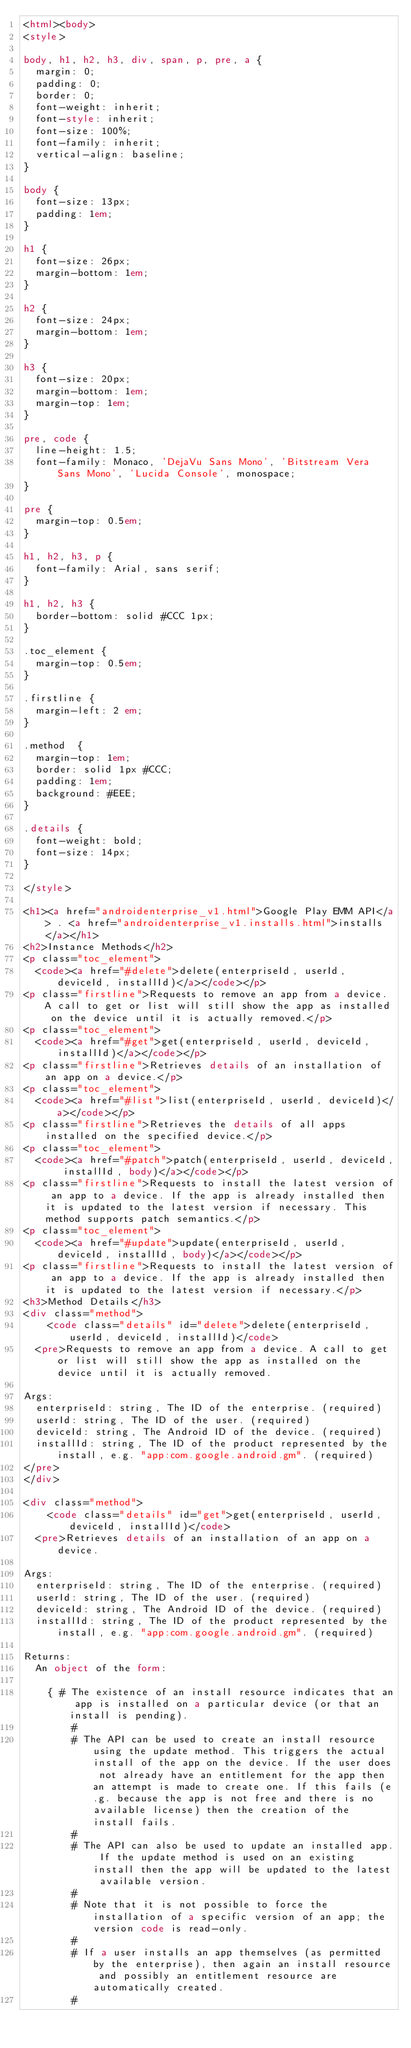Convert code to text. <code><loc_0><loc_0><loc_500><loc_500><_HTML_><html><body>
<style>

body, h1, h2, h3, div, span, p, pre, a {
  margin: 0;
  padding: 0;
  border: 0;
  font-weight: inherit;
  font-style: inherit;
  font-size: 100%;
  font-family: inherit;
  vertical-align: baseline;
}

body {
  font-size: 13px;
  padding: 1em;
}

h1 {
  font-size: 26px;
  margin-bottom: 1em;
}

h2 {
  font-size: 24px;
  margin-bottom: 1em;
}

h3 {
  font-size: 20px;
  margin-bottom: 1em;
  margin-top: 1em;
}

pre, code {
  line-height: 1.5;
  font-family: Monaco, 'DejaVu Sans Mono', 'Bitstream Vera Sans Mono', 'Lucida Console', monospace;
}

pre {
  margin-top: 0.5em;
}

h1, h2, h3, p {
  font-family: Arial, sans serif;
}

h1, h2, h3 {
  border-bottom: solid #CCC 1px;
}

.toc_element {
  margin-top: 0.5em;
}

.firstline {
  margin-left: 2 em;
}

.method  {
  margin-top: 1em;
  border: solid 1px #CCC;
  padding: 1em;
  background: #EEE;
}

.details {
  font-weight: bold;
  font-size: 14px;
}

</style>

<h1><a href="androidenterprise_v1.html">Google Play EMM API</a> . <a href="androidenterprise_v1.installs.html">installs</a></h1>
<h2>Instance Methods</h2>
<p class="toc_element">
  <code><a href="#delete">delete(enterpriseId, userId, deviceId, installId)</a></code></p>
<p class="firstline">Requests to remove an app from a device. A call to get or list will still show the app as installed on the device until it is actually removed.</p>
<p class="toc_element">
  <code><a href="#get">get(enterpriseId, userId, deviceId, installId)</a></code></p>
<p class="firstline">Retrieves details of an installation of an app on a device.</p>
<p class="toc_element">
  <code><a href="#list">list(enterpriseId, userId, deviceId)</a></code></p>
<p class="firstline">Retrieves the details of all apps installed on the specified device.</p>
<p class="toc_element">
  <code><a href="#patch">patch(enterpriseId, userId, deviceId, installId, body)</a></code></p>
<p class="firstline">Requests to install the latest version of an app to a device. If the app is already installed then it is updated to the latest version if necessary. This method supports patch semantics.</p>
<p class="toc_element">
  <code><a href="#update">update(enterpriseId, userId, deviceId, installId, body)</a></code></p>
<p class="firstline">Requests to install the latest version of an app to a device. If the app is already installed then it is updated to the latest version if necessary.</p>
<h3>Method Details</h3>
<div class="method">
    <code class="details" id="delete">delete(enterpriseId, userId, deviceId, installId)</code>
  <pre>Requests to remove an app from a device. A call to get or list will still show the app as installed on the device until it is actually removed.

Args:
  enterpriseId: string, The ID of the enterprise. (required)
  userId: string, The ID of the user. (required)
  deviceId: string, The Android ID of the device. (required)
  installId: string, The ID of the product represented by the install, e.g. "app:com.google.android.gm". (required)
</pre>
</div>

<div class="method">
    <code class="details" id="get">get(enterpriseId, userId, deviceId, installId)</code>
  <pre>Retrieves details of an installation of an app on a device.

Args:
  enterpriseId: string, The ID of the enterprise. (required)
  userId: string, The ID of the user. (required)
  deviceId: string, The Android ID of the device. (required)
  installId: string, The ID of the product represented by the install, e.g. "app:com.google.android.gm". (required)

Returns:
  An object of the form:

    { # The existence of an install resource indicates that an app is installed on a particular device (or that an install is pending).
        #
        # The API can be used to create an install resource using the update method. This triggers the actual install of the app on the device. If the user does not already have an entitlement for the app then an attempt is made to create one. If this fails (e.g. because the app is not free and there is no available license) then the creation of the install fails.
        #
        # The API can also be used to update an installed app. If the update method is used on an existing install then the app will be updated to the latest available version.
        #
        # Note that it is not possible to force the installation of a specific version of an app; the version code is read-only.
        #
        # If a user installs an app themselves (as permitted by the enterprise), then again an install resource and possibly an entitlement resource are automatically created.
        #</code> 